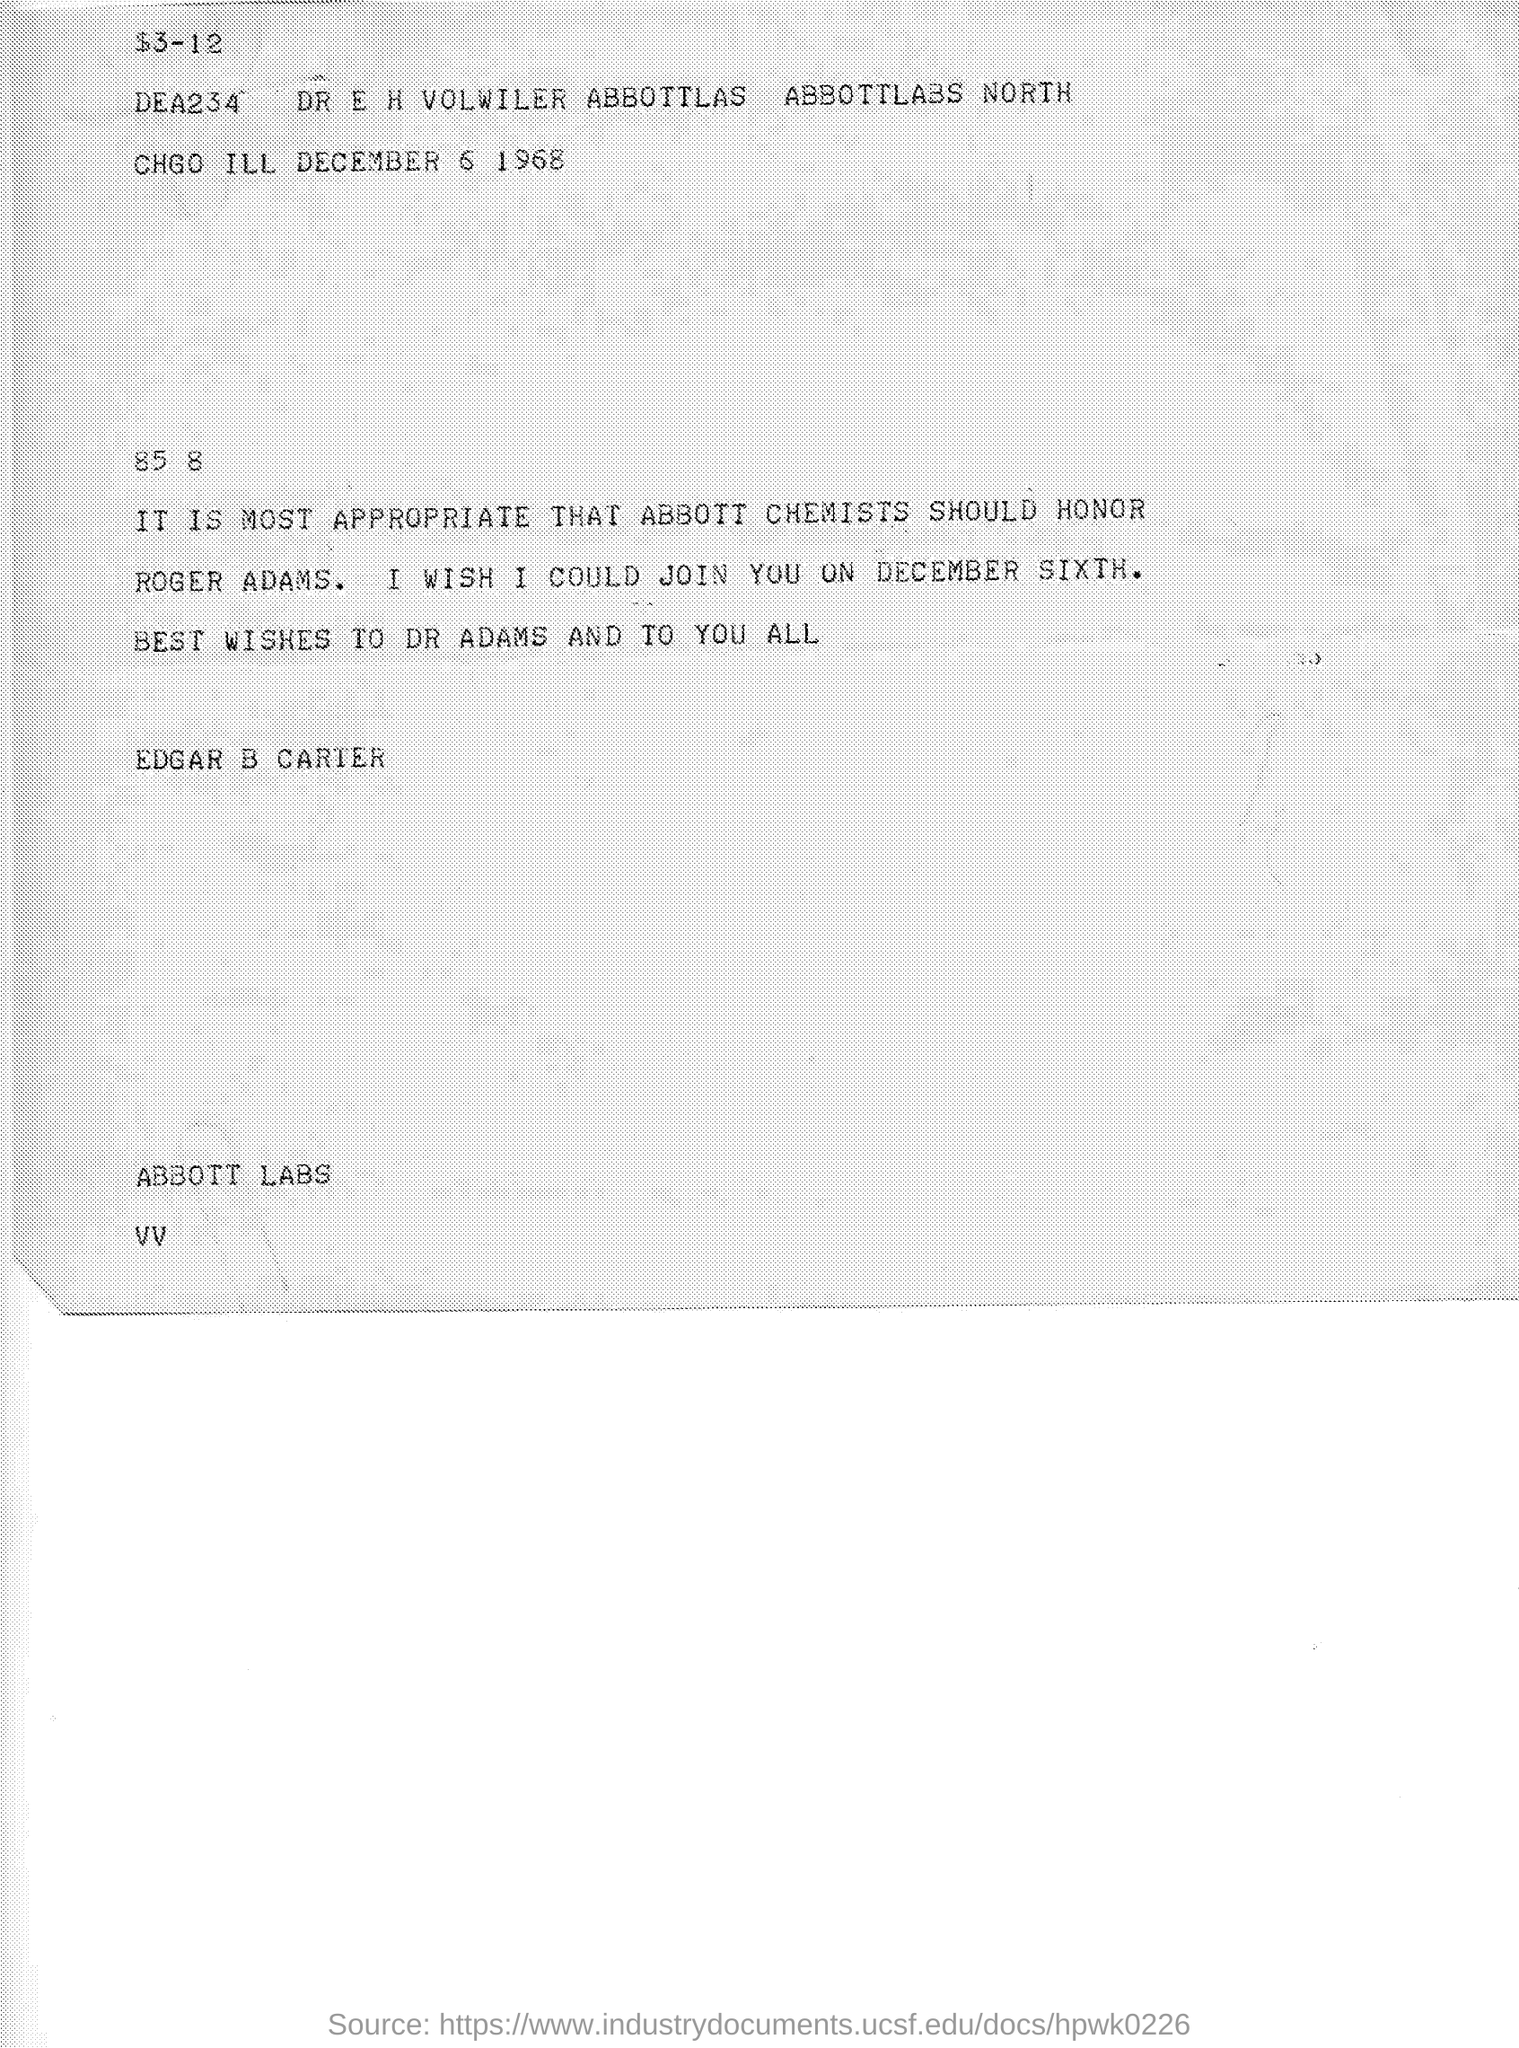Who is the sender?
Make the answer very short. EDGAR B CARTER. When is the program?
Your answer should be very brief. DECEMBER SIXTH. When is the document dated?
Your answer should be very brief. December 6 1968. 